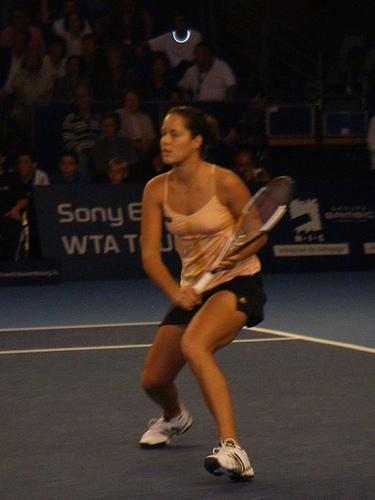How many people are in the photo?
Give a very brief answer. 5. How many cats are here?
Give a very brief answer. 0. 